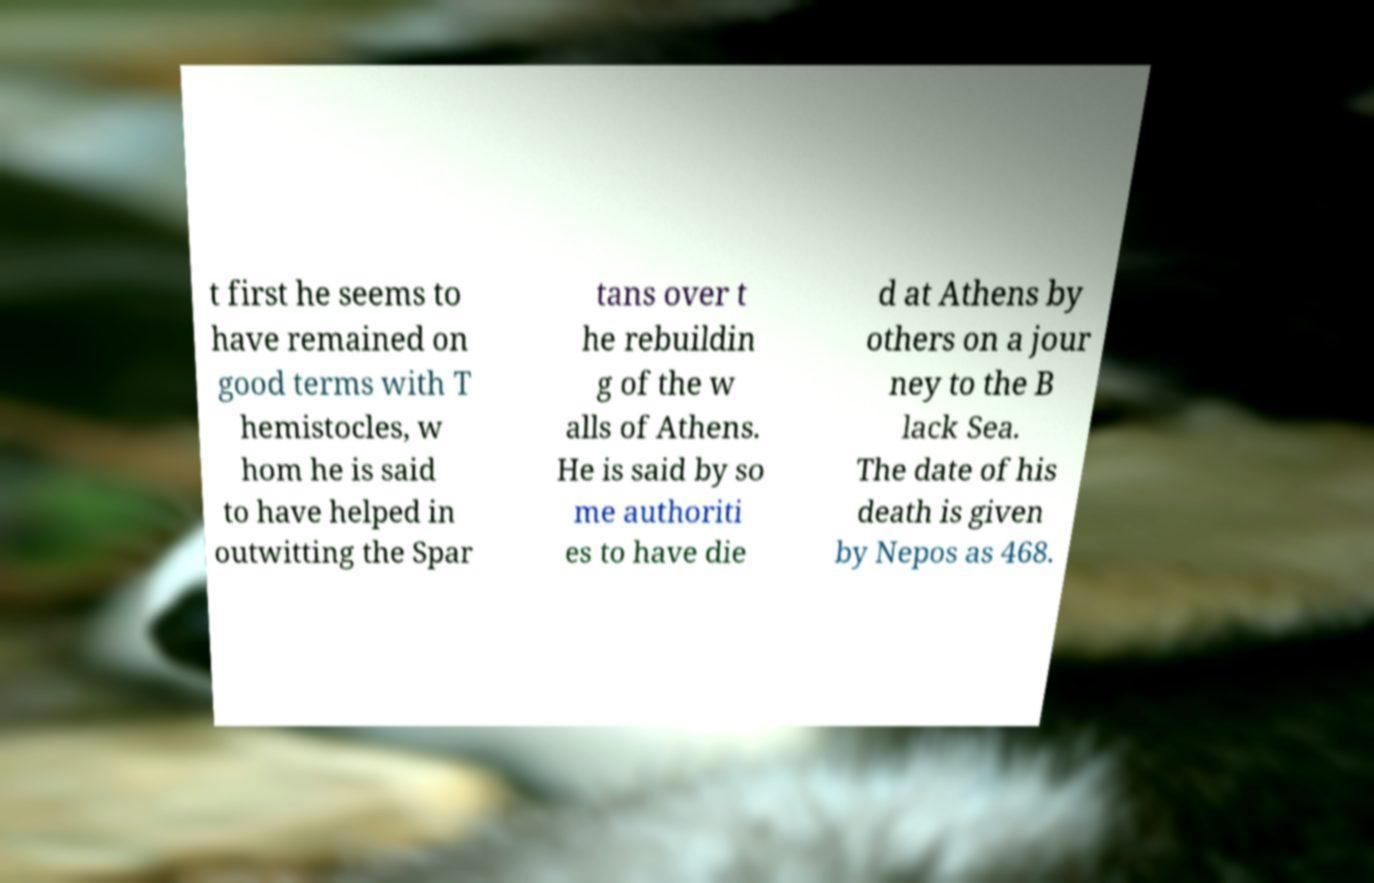Please identify and transcribe the text found in this image. t first he seems to have remained on good terms with T hemistocles, w hom he is said to have helped in outwitting the Spar tans over t he rebuildin g of the w alls of Athens. He is said by so me authoriti es to have die d at Athens by others on a jour ney to the B lack Sea. The date of his death is given by Nepos as 468. 